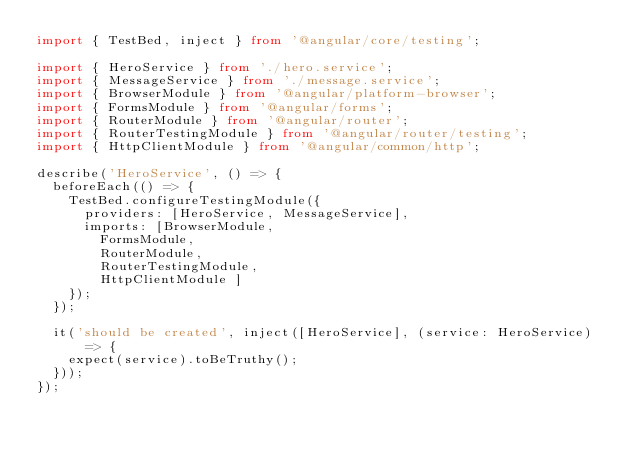Convert code to text. <code><loc_0><loc_0><loc_500><loc_500><_TypeScript_>import { TestBed, inject } from '@angular/core/testing';

import { HeroService } from './hero.service';
import { MessageService } from './message.service';
import { BrowserModule } from '@angular/platform-browser';
import { FormsModule } from '@angular/forms';
import { RouterModule } from '@angular/router';
import { RouterTestingModule } from '@angular/router/testing';
import { HttpClientModule } from '@angular/common/http';

describe('HeroService', () => {
  beforeEach(() => {
    TestBed.configureTestingModule({
      providers: [HeroService, MessageService],
      imports: [BrowserModule,
        FormsModule,
        RouterModule,
        RouterTestingModule,
        HttpClientModule ]
    });
  });

  it('should be created', inject([HeroService], (service: HeroService) => {
    expect(service).toBeTruthy();
  }));
});
</code> 